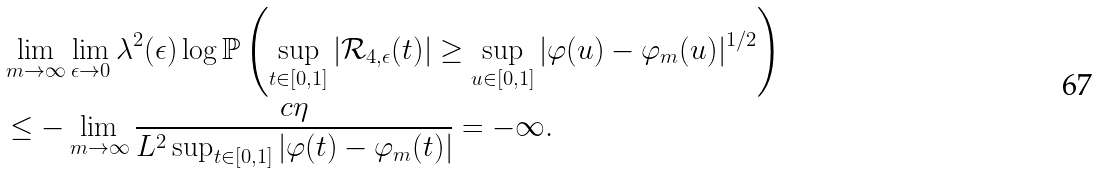Convert formula to latex. <formula><loc_0><loc_0><loc_500><loc_500>& \lim _ { m \to \infty } \lim _ { \epsilon \to 0 } \lambda ^ { 2 } ( \epsilon ) \log \mathbb { P } \left ( \sup _ { t \in [ 0 , 1 ] } | \mathcal { R } _ { 4 , \epsilon } ( t ) | \geq \sup _ { u \in [ 0 , 1 ] } | \varphi ( u ) - \varphi _ { m } ( u ) | ^ { 1 / 2 } \right ) \\ & \leq - \lim _ { m \to \infty } \frac { c \eta } { L ^ { 2 } \sup _ { t \in [ 0 , 1 ] } | \varphi ( t ) - \varphi _ { m } ( t ) | } = - \infty .</formula> 